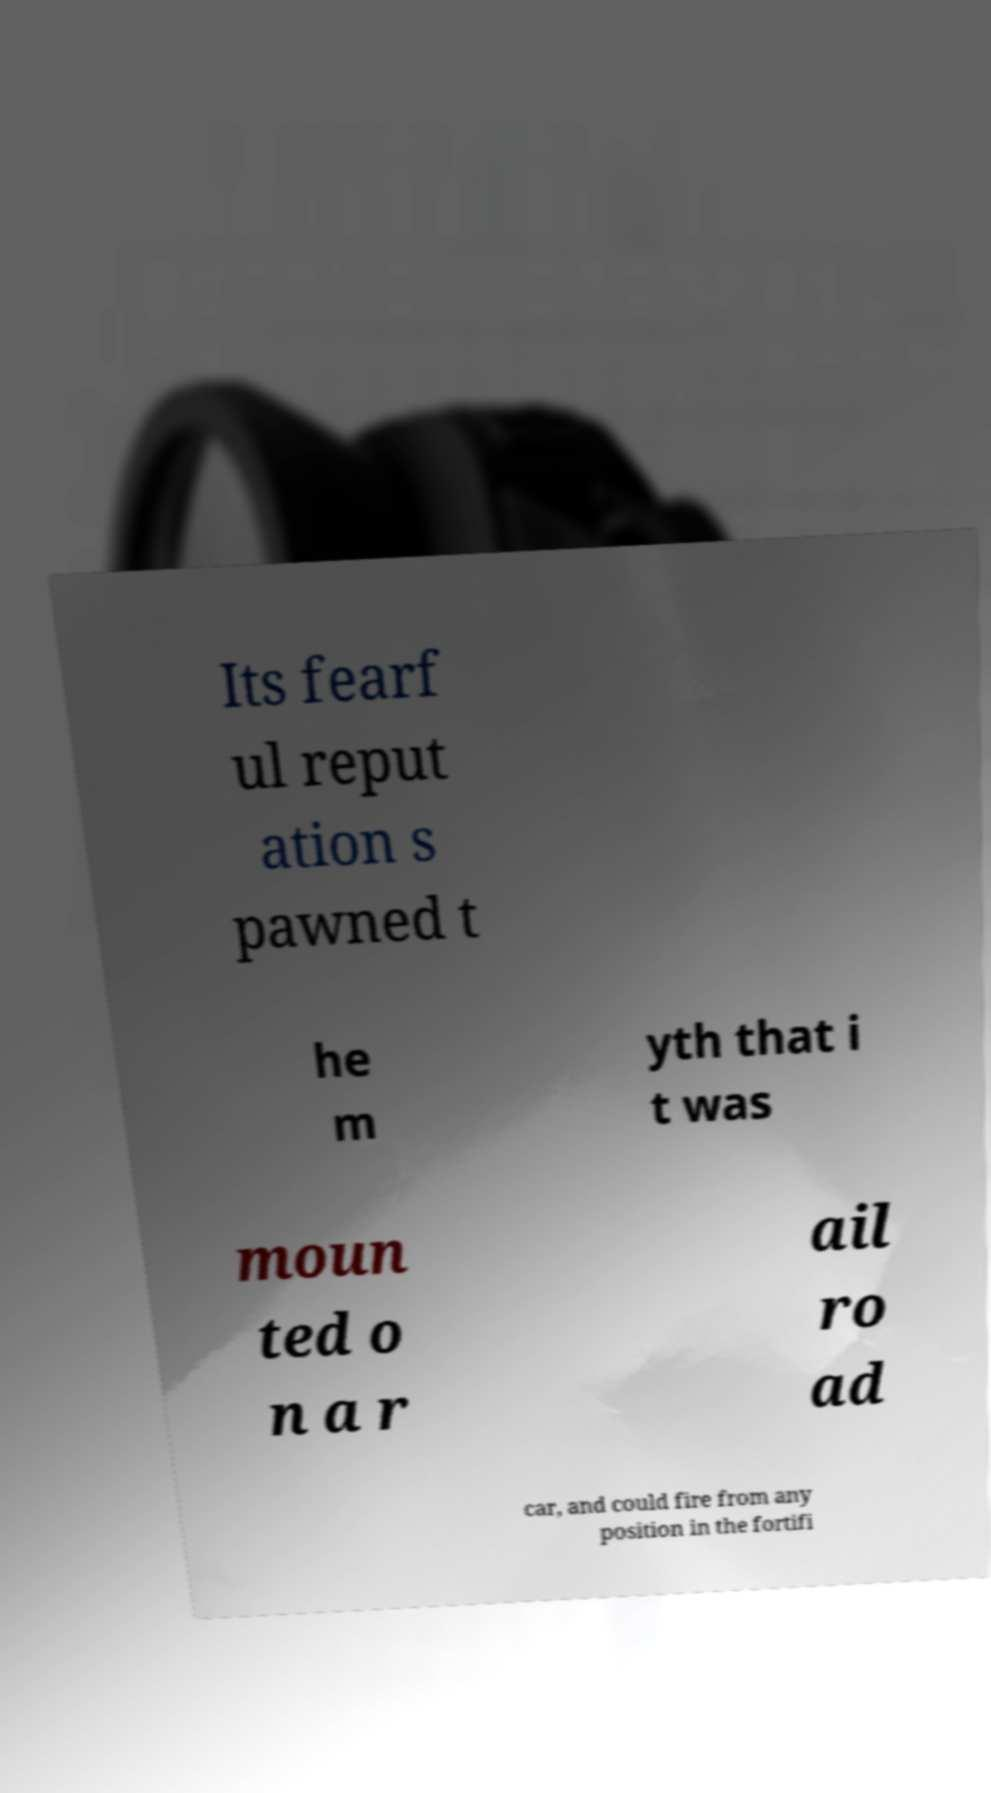Can you read and provide the text displayed in the image?This photo seems to have some interesting text. Can you extract and type it out for me? Its fearf ul reput ation s pawned t he m yth that i t was moun ted o n a r ail ro ad car, and could fire from any position in the fortifi 